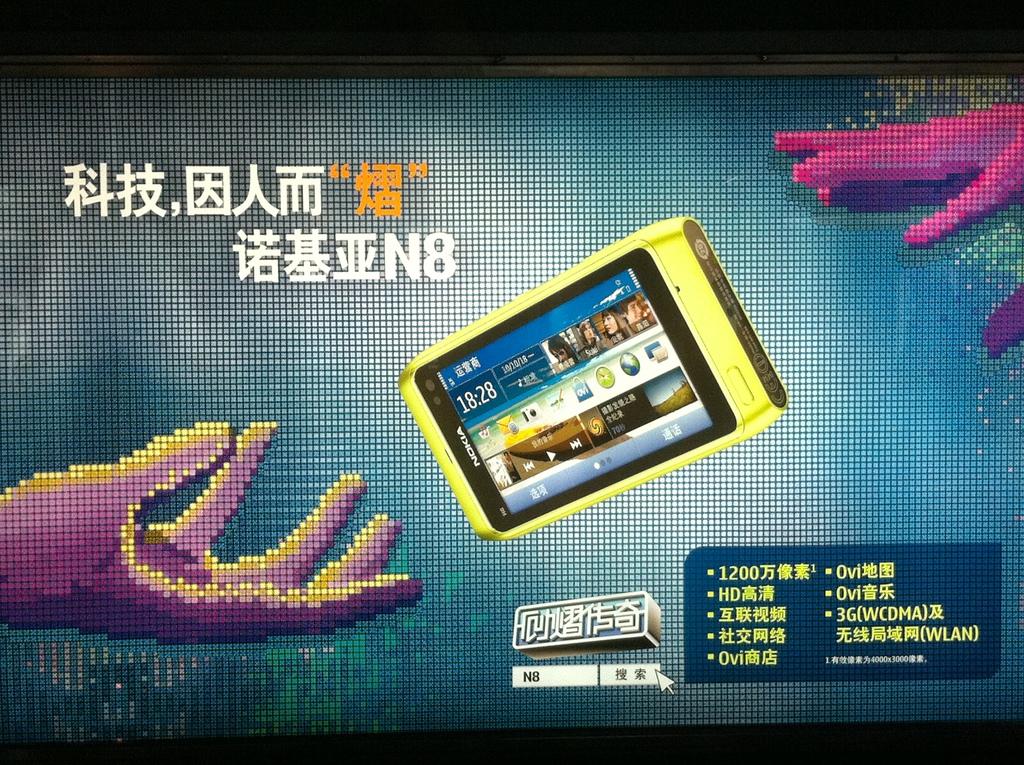What brand of cell phone is this?
Keep it short and to the point. Nokia. What is the time on the device?
Your answer should be compact. 18:28. 